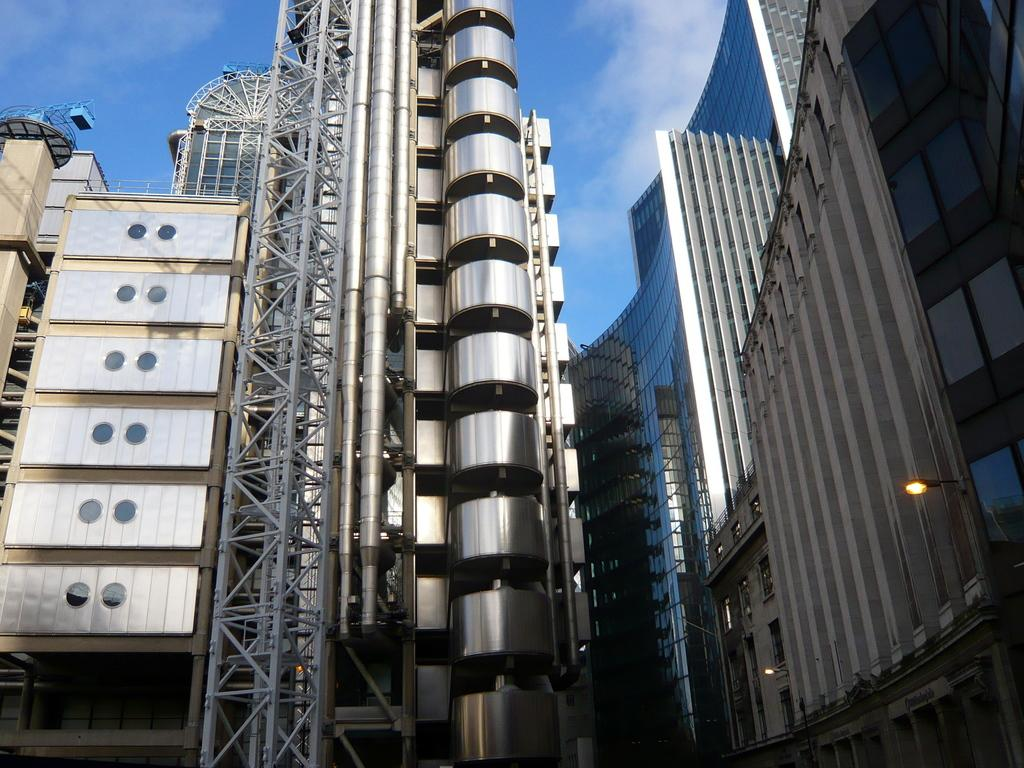What type of structures are present in the image? There are buildings in the image. Where is the light located in the image? The light is on the right side of the image. What is visible at the top of the image? The sky is visible at the top of the image. What is the price of the cave in the image? There is no cave present in the image, so it is not possible to determine its price. 